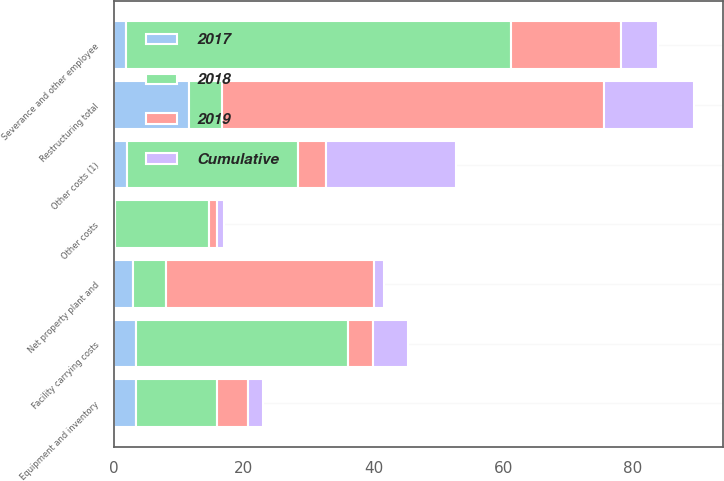Convert chart. <chart><loc_0><loc_0><loc_500><loc_500><stacked_bar_chart><ecel><fcel>Net property plant and<fcel>Severance and other employee<fcel>Equipment and inventory<fcel>Facility carrying costs<fcel>Other costs<fcel>Restructuring total<fcel>Other costs (1)<nl><fcel>2019<fcel>32.1<fcel>16.9<fcel>4.8<fcel>3.9<fcel>1.2<fcel>58.9<fcel>4.3<nl><fcel>2017<fcel>2.9<fcel>1.9<fcel>3.4<fcel>3.3<fcel>0.1<fcel>11.6<fcel>2<nl><fcel>Cumulative<fcel>1.5<fcel>5.8<fcel>2.2<fcel>5.4<fcel>1.1<fcel>13.8<fcel>20.1<nl><fcel>2018<fcel>5.1<fcel>59.3<fcel>12.5<fcel>32.7<fcel>14.5<fcel>5.1<fcel>26.4<nl></chart> 